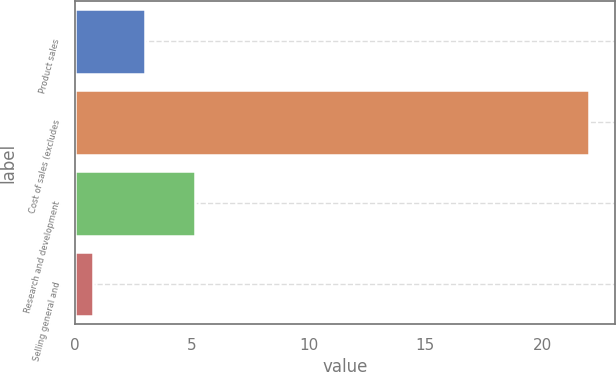Convert chart to OTSL. <chart><loc_0><loc_0><loc_500><loc_500><bar_chart><fcel>Product sales<fcel>Cost of sales (excludes<fcel>Research and development<fcel>Selling general and<nl><fcel>3<fcel>22<fcel>5.12<fcel>0.78<nl></chart> 